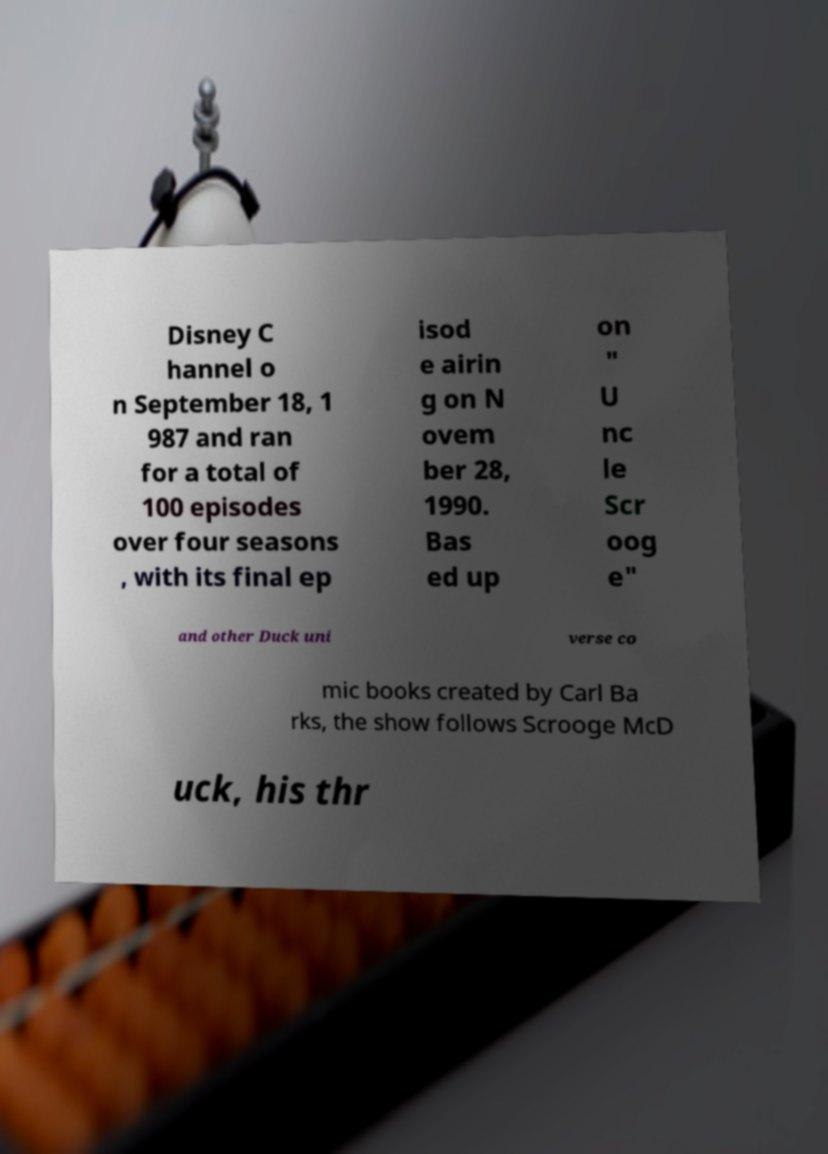Please read and relay the text visible in this image. What does it say? Disney C hannel o n September 18, 1 987 and ran for a total of 100 episodes over four seasons , with its final ep isod e airin g on N ovem ber 28, 1990. Bas ed up on " U nc le Scr oog e" and other Duck uni verse co mic books created by Carl Ba rks, the show follows Scrooge McD uck, his thr 